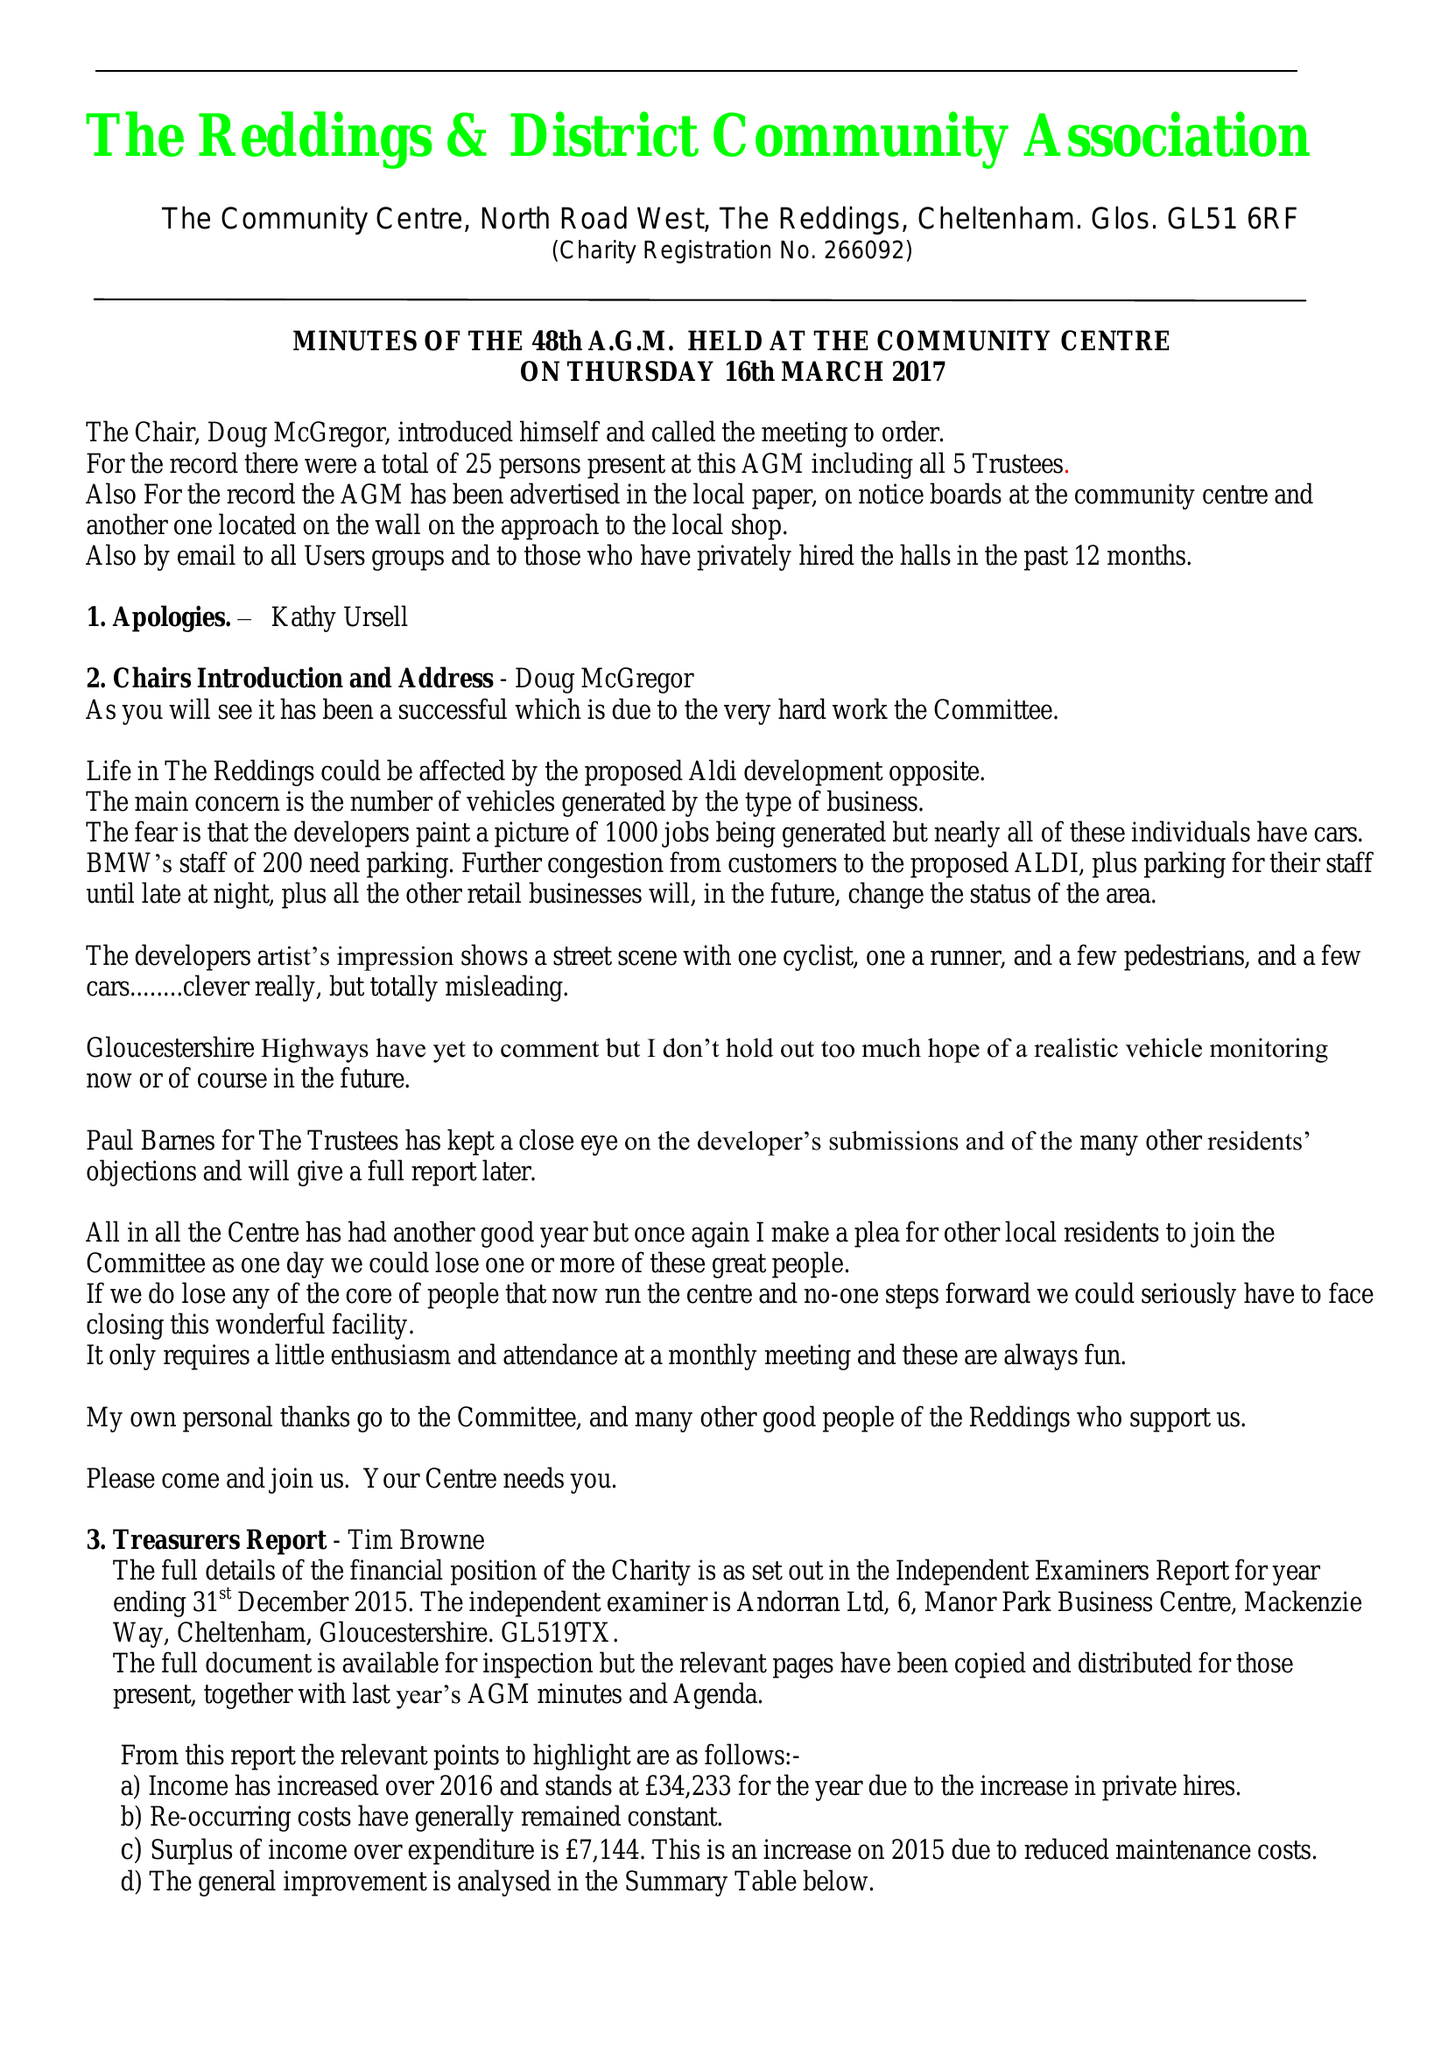What is the value for the report_date?
Answer the question using a single word or phrase. 2016-12-31 